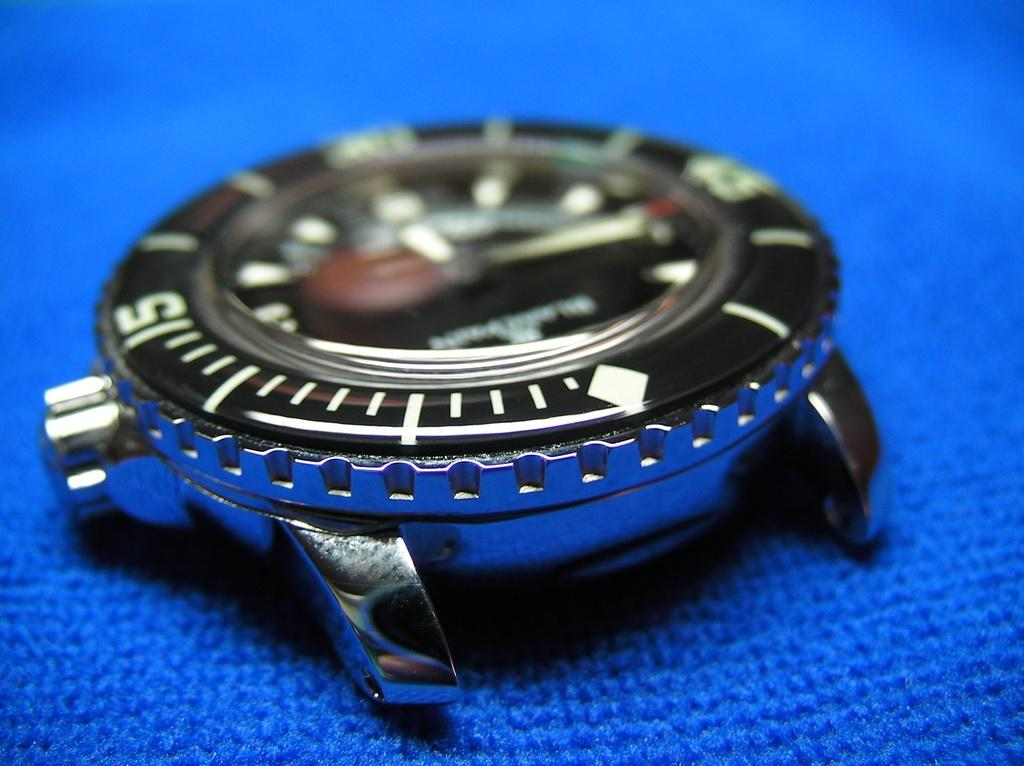<image>
Present a compact description of the photo's key features. A somewhat blurry number 5 is visible on a watch face. 